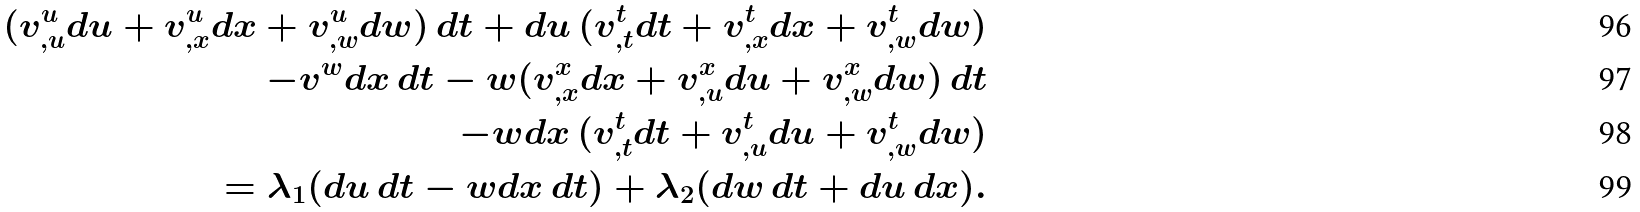<formula> <loc_0><loc_0><loc_500><loc_500>( v ^ { u } _ { , u } d u + v ^ { u } _ { , x } d x + v ^ { u } _ { , w } d w ) \, d t + d u \, ( v ^ { t } _ { , t } d t + v ^ { t } _ { , x } d x + v ^ { t } _ { , w } d w ) \\ - v ^ { w } d x \, d t - w ( v ^ { x } _ { , x } d x + v ^ { x } _ { , u } d u + v ^ { x } _ { , w } d w ) \, d t \\ - w d x \, ( v ^ { t } _ { , t } d t + v ^ { t } _ { , u } d u + v ^ { t } _ { , w } d w ) \\ = \lambda _ { 1 } ( d u \, d t - w d x \, d t ) + \lambda _ { 2 } ( d w \, d t + d u \, d x ) .</formula> 